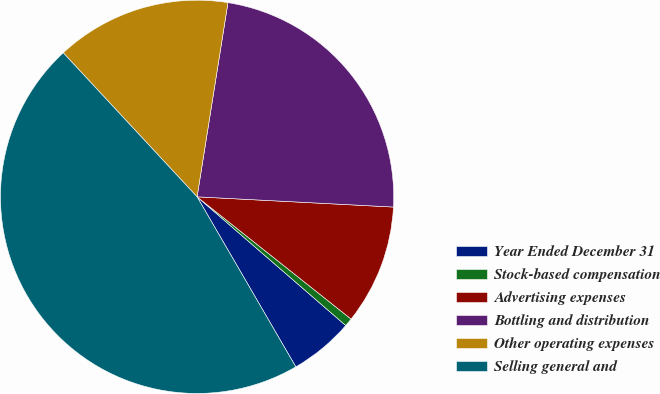Convert chart to OTSL. <chart><loc_0><loc_0><loc_500><loc_500><pie_chart><fcel>Year Ended December 31<fcel>Stock-based compensation<fcel>Advertising expenses<fcel>Bottling and distribution<fcel>Other operating expenses<fcel>Selling general and<nl><fcel>5.27%<fcel>0.68%<fcel>9.85%<fcel>23.32%<fcel>14.43%<fcel>46.46%<nl></chart> 